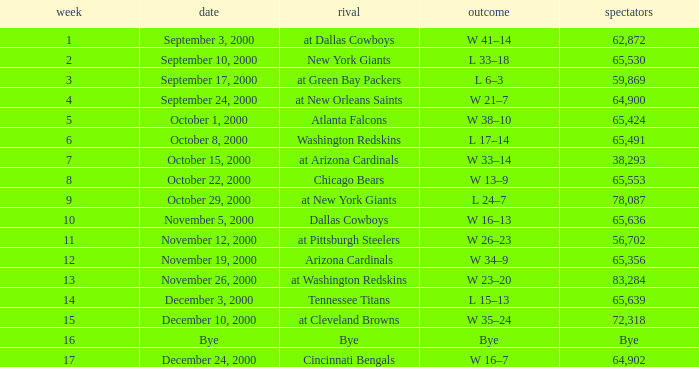What was the attendance for week 2? 65530.0. 